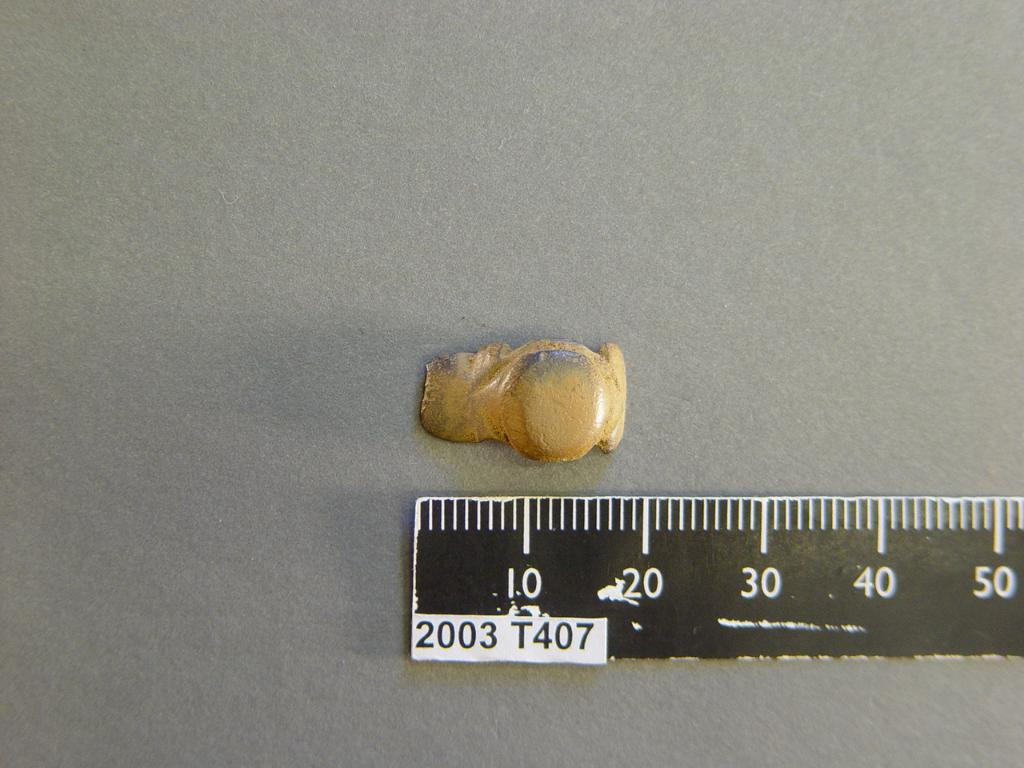<image>
Describe the image concisely. A 2003 T407 black ruler is measuring a small goldish item 